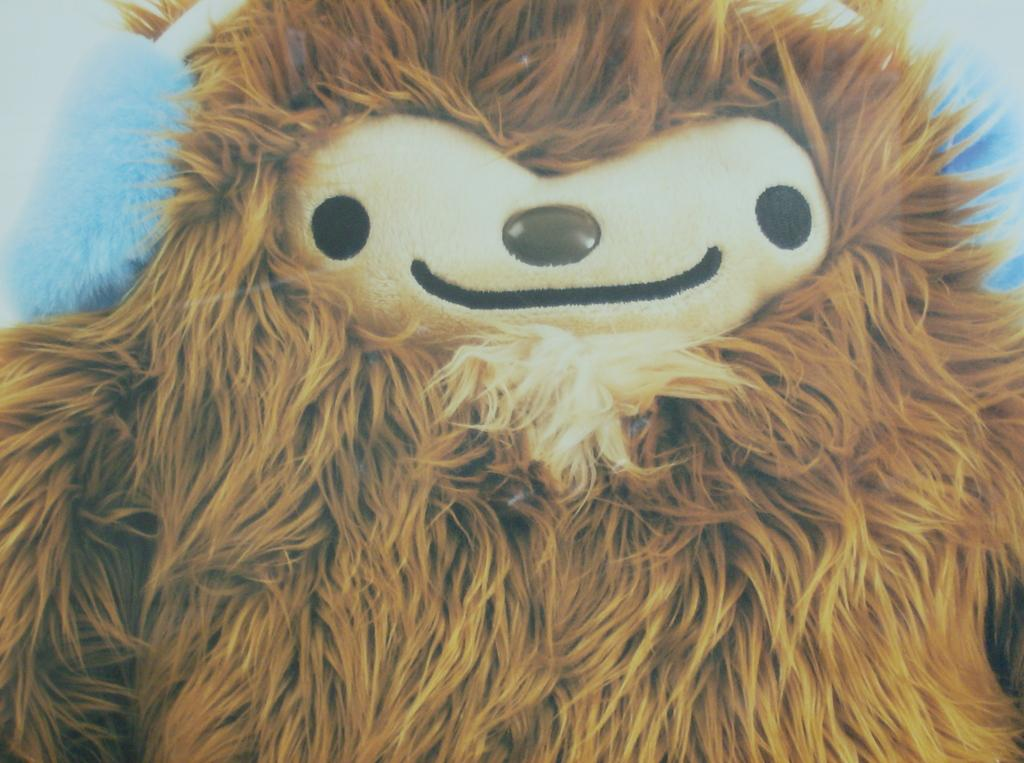What type of object can be seen in the image? There is a soft toy in the image. What type of stitch is used to repair the dad's tub in the image? There is no dad, tub, or stitch present in the image; it only features a soft toy. 